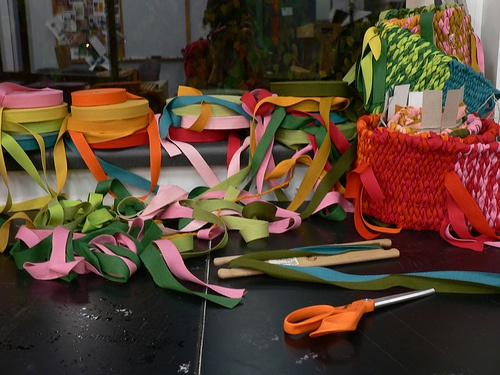Describe the objects in this image and their specific colors. I can see scissors in gray, red, black, maroon, and brown tones in this image. 